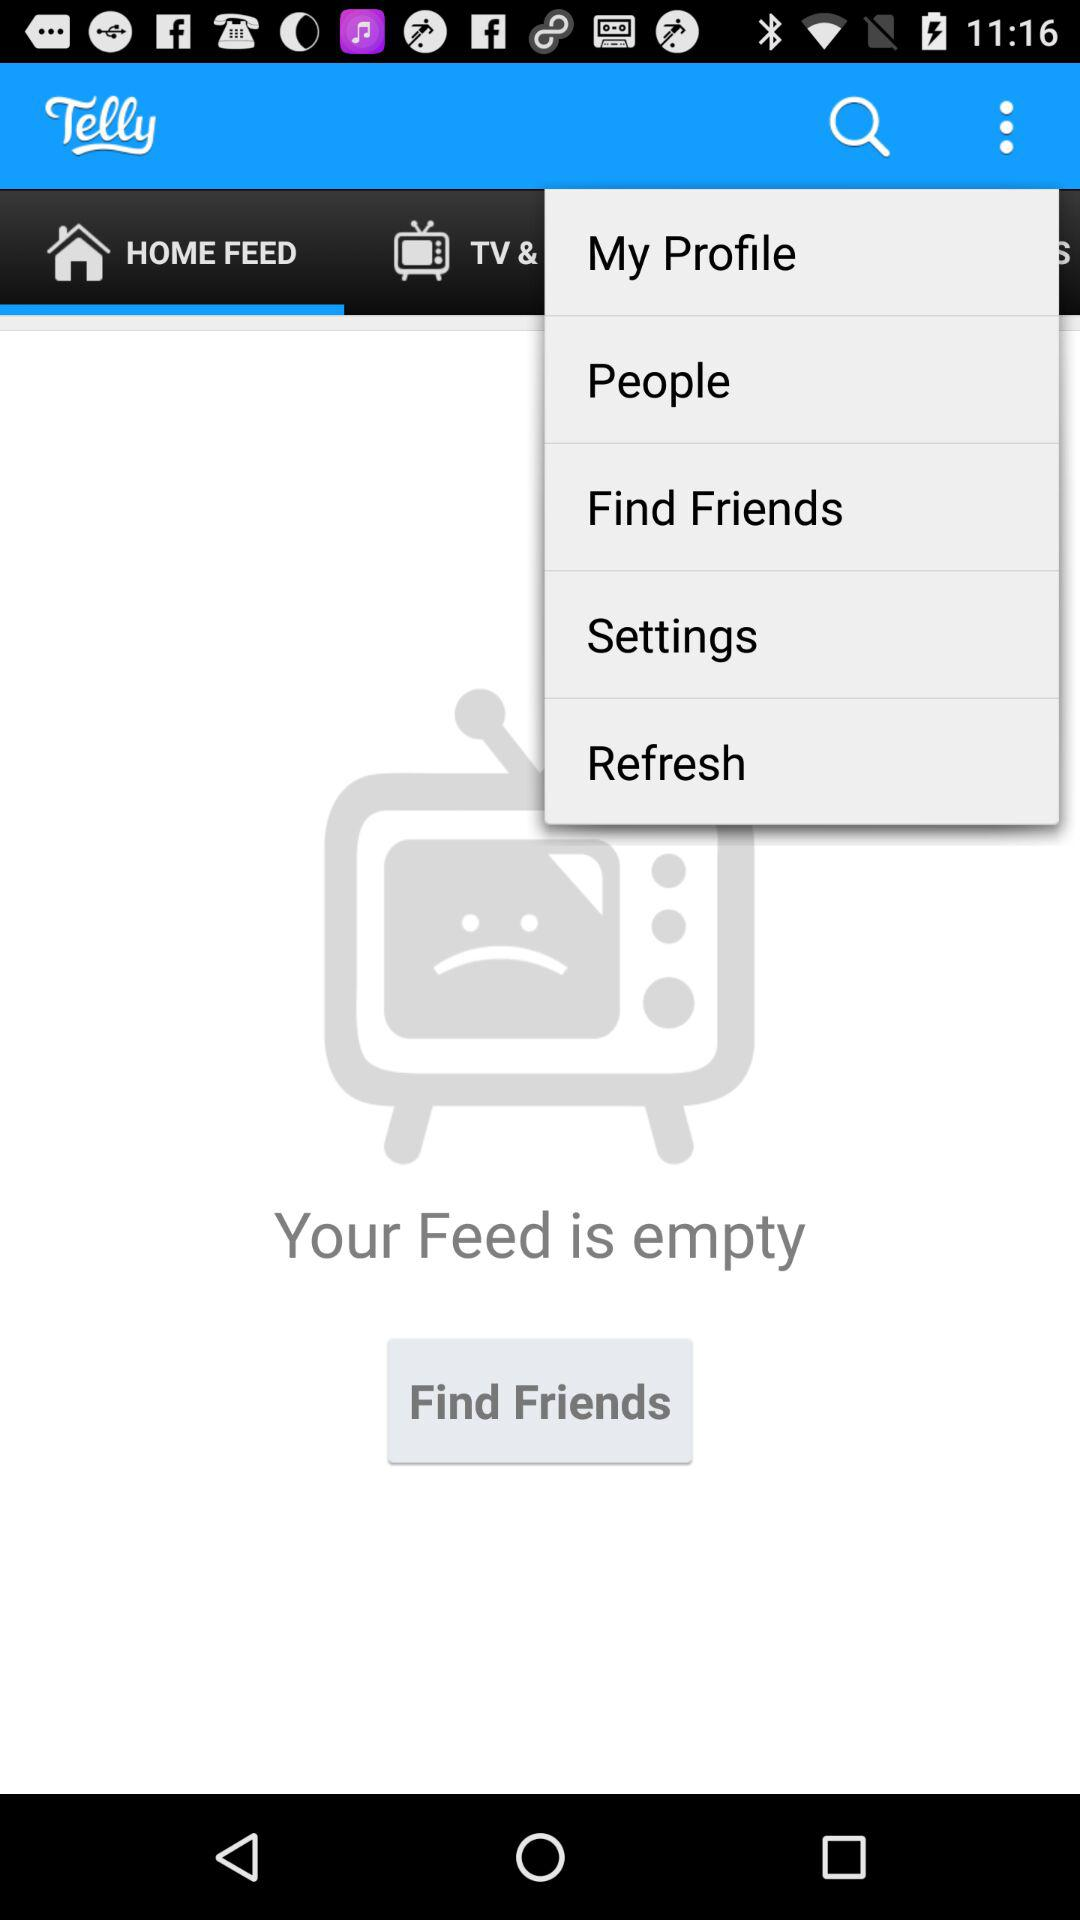What is the status of "Feed"? The status is "empty". 